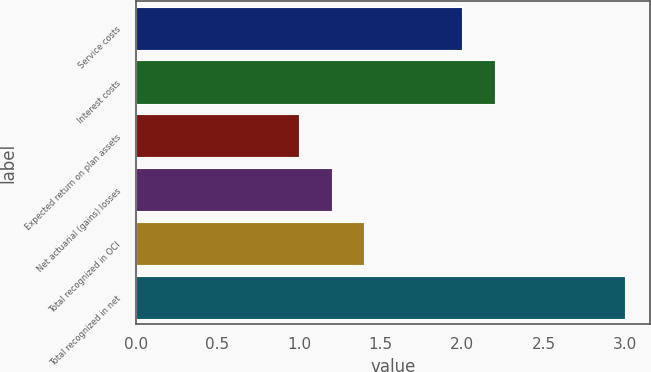Convert chart. <chart><loc_0><loc_0><loc_500><loc_500><bar_chart><fcel>Service costs<fcel>Interest costs<fcel>Expected return on plan assets<fcel>Net actuarial (gains) losses<fcel>Total recognized in OCI<fcel>Total recognized in net<nl><fcel>2<fcel>2.2<fcel>1<fcel>1.2<fcel>1.4<fcel>3<nl></chart> 